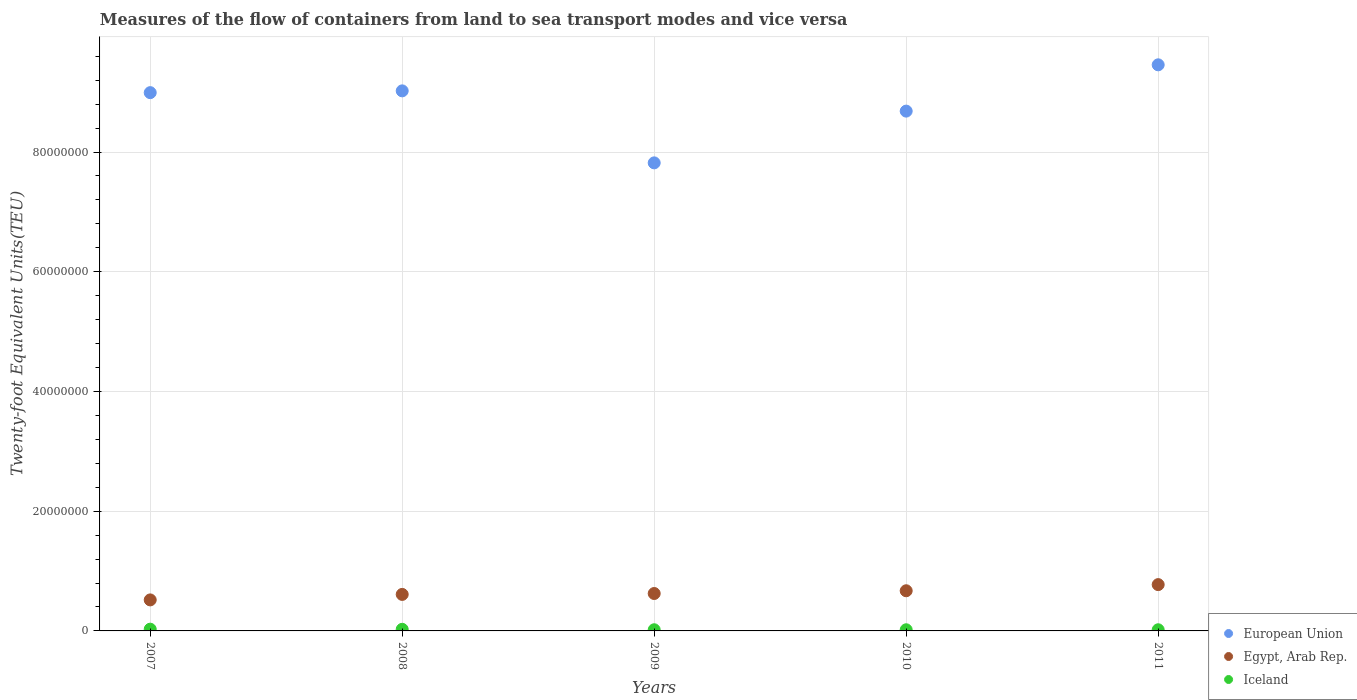What is the container port traffic in Iceland in 2011?
Ensure brevity in your answer.  1.94e+05. Across all years, what is the maximum container port traffic in European Union?
Your answer should be compact. 9.46e+07. Across all years, what is the minimum container port traffic in Iceland?
Make the answer very short. 1.93e+05. In which year was the container port traffic in European Union maximum?
Ensure brevity in your answer.  2011. In which year was the container port traffic in Egypt, Arab Rep. minimum?
Your answer should be compact. 2007. What is the total container port traffic in European Union in the graph?
Offer a very short reply. 4.40e+08. What is the difference between the container port traffic in European Union in 2008 and that in 2010?
Offer a terse response. 3.38e+06. What is the difference between the container port traffic in European Union in 2007 and the container port traffic in Iceland in 2010?
Make the answer very short. 8.97e+07. What is the average container port traffic in Iceland per year?
Give a very brief answer. 2.28e+05. In the year 2008, what is the difference between the container port traffic in Egypt, Arab Rep. and container port traffic in European Union?
Provide a succinct answer. -8.41e+07. In how many years, is the container port traffic in Iceland greater than 40000000 TEU?
Keep it short and to the point. 0. What is the ratio of the container port traffic in Egypt, Arab Rep. in 2008 to that in 2010?
Provide a short and direct response. 0.91. Is the container port traffic in European Union in 2007 less than that in 2010?
Keep it short and to the point. No. What is the difference between the highest and the second highest container port traffic in Iceland?
Provide a short and direct response. 2.46e+04. What is the difference between the highest and the lowest container port traffic in European Union?
Make the answer very short. 1.64e+07. In how many years, is the container port traffic in European Union greater than the average container port traffic in European Union taken over all years?
Keep it short and to the point. 3. Does the container port traffic in Iceland monotonically increase over the years?
Keep it short and to the point. No. Does the graph contain grids?
Make the answer very short. Yes. How many legend labels are there?
Offer a very short reply. 3. What is the title of the graph?
Ensure brevity in your answer.  Measures of the flow of containers from land to sea transport modes and vice versa. Does "Togo" appear as one of the legend labels in the graph?
Provide a short and direct response. No. What is the label or title of the X-axis?
Your response must be concise. Years. What is the label or title of the Y-axis?
Offer a very short reply. Twenty-foot Equivalent Units(TEU). What is the Twenty-foot Equivalent Units(TEU) in European Union in 2007?
Your answer should be very brief. 8.99e+07. What is the Twenty-foot Equivalent Units(TEU) of Egypt, Arab Rep. in 2007?
Give a very brief answer. 5.18e+06. What is the Twenty-foot Equivalent Units(TEU) in Iceland in 2007?
Ensure brevity in your answer.  2.92e+05. What is the Twenty-foot Equivalent Units(TEU) in European Union in 2008?
Keep it short and to the point. 9.02e+07. What is the Twenty-foot Equivalent Units(TEU) in Egypt, Arab Rep. in 2008?
Offer a very short reply. 6.10e+06. What is the Twenty-foot Equivalent Units(TEU) of Iceland in 2008?
Your answer should be very brief. 2.67e+05. What is the Twenty-foot Equivalent Units(TEU) in European Union in 2009?
Offer a very short reply. 7.82e+07. What is the Twenty-foot Equivalent Units(TEU) of Egypt, Arab Rep. in 2009?
Provide a short and direct response. 6.25e+06. What is the Twenty-foot Equivalent Units(TEU) in Iceland in 2009?
Give a very brief answer. 1.94e+05. What is the Twenty-foot Equivalent Units(TEU) of European Union in 2010?
Offer a very short reply. 8.68e+07. What is the Twenty-foot Equivalent Units(TEU) in Egypt, Arab Rep. in 2010?
Offer a very short reply. 6.71e+06. What is the Twenty-foot Equivalent Units(TEU) in Iceland in 2010?
Give a very brief answer. 1.93e+05. What is the Twenty-foot Equivalent Units(TEU) in European Union in 2011?
Your response must be concise. 9.46e+07. What is the Twenty-foot Equivalent Units(TEU) in Egypt, Arab Rep. in 2011?
Provide a succinct answer. 7.74e+06. What is the Twenty-foot Equivalent Units(TEU) of Iceland in 2011?
Ensure brevity in your answer.  1.94e+05. Across all years, what is the maximum Twenty-foot Equivalent Units(TEU) in European Union?
Keep it short and to the point. 9.46e+07. Across all years, what is the maximum Twenty-foot Equivalent Units(TEU) of Egypt, Arab Rep.?
Give a very brief answer. 7.74e+06. Across all years, what is the maximum Twenty-foot Equivalent Units(TEU) of Iceland?
Offer a very short reply. 2.92e+05. Across all years, what is the minimum Twenty-foot Equivalent Units(TEU) in European Union?
Your answer should be very brief. 7.82e+07. Across all years, what is the minimum Twenty-foot Equivalent Units(TEU) of Egypt, Arab Rep.?
Keep it short and to the point. 5.18e+06. Across all years, what is the minimum Twenty-foot Equivalent Units(TEU) of Iceland?
Keep it short and to the point. 1.93e+05. What is the total Twenty-foot Equivalent Units(TEU) in European Union in the graph?
Your response must be concise. 4.40e+08. What is the total Twenty-foot Equivalent Units(TEU) in Egypt, Arab Rep. in the graph?
Ensure brevity in your answer.  3.20e+07. What is the total Twenty-foot Equivalent Units(TEU) of Iceland in the graph?
Provide a short and direct response. 1.14e+06. What is the difference between the Twenty-foot Equivalent Units(TEU) in European Union in 2007 and that in 2008?
Offer a very short reply. -2.98e+05. What is the difference between the Twenty-foot Equivalent Units(TEU) in Egypt, Arab Rep. in 2007 and that in 2008?
Ensure brevity in your answer.  -9.18e+05. What is the difference between the Twenty-foot Equivalent Units(TEU) of Iceland in 2007 and that in 2008?
Make the answer very short. 2.46e+04. What is the difference between the Twenty-foot Equivalent Units(TEU) in European Union in 2007 and that in 2009?
Give a very brief answer. 1.17e+07. What is the difference between the Twenty-foot Equivalent Units(TEU) in Egypt, Arab Rep. in 2007 and that in 2009?
Provide a succinct answer. -1.07e+06. What is the difference between the Twenty-foot Equivalent Units(TEU) of Iceland in 2007 and that in 2009?
Keep it short and to the point. 9.79e+04. What is the difference between the Twenty-foot Equivalent Units(TEU) in European Union in 2007 and that in 2010?
Your response must be concise. 3.09e+06. What is the difference between the Twenty-foot Equivalent Units(TEU) of Egypt, Arab Rep. in 2007 and that in 2010?
Your response must be concise. -1.53e+06. What is the difference between the Twenty-foot Equivalent Units(TEU) in Iceland in 2007 and that in 2010?
Ensure brevity in your answer.  9.90e+04. What is the difference between the Twenty-foot Equivalent Units(TEU) of European Union in 2007 and that in 2011?
Provide a short and direct response. -4.65e+06. What is the difference between the Twenty-foot Equivalent Units(TEU) of Egypt, Arab Rep. in 2007 and that in 2011?
Your answer should be very brief. -2.56e+06. What is the difference between the Twenty-foot Equivalent Units(TEU) of Iceland in 2007 and that in 2011?
Your response must be concise. 9.82e+04. What is the difference between the Twenty-foot Equivalent Units(TEU) of European Union in 2008 and that in 2009?
Offer a very short reply. 1.20e+07. What is the difference between the Twenty-foot Equivalent Units(TEU) of Egypt, Arab Rep. in 2008 and that in 2009?
Offer a very short reply. -1.51e+05. What is the difference between the Twenty-foot Equivalent Units(TEU) in Iceland in 2008 and that in 2009?
Offer a very short reply. 7.33e+04. What is the difference between the Twenty-foot Equivalent Units(TEU) of European Union in 2008 and that in 2010?
Provide a short and direct response. 3.38e+06. What is the difference between the Twenty-foot Equivalent Units(TEU) in Egypt, Arab Rep. in 2008 and that in 2010?
Offer a very short reply. -6.10e+05. What is the difference between the Twenty-foot Equivalent Units(TEU) of Iceland in 2008 and that in 2010?
Your answer should be very brief. 7.44e+04. What is the difference between the Twenty-foot Equivalent Units(TEU) of European Union in 2008 and that in 2011?
Your answer should be very brief. -4.35e+06. What is the difference between the Twenty-foot Equivalent Units(TEU) of Egypt, Arab Rep. in 2008 and that in 2011?
Give a very brief answer. -1.64e+06. What is the difference between the Twenty-foot Equivalent Units(TEU) in Iceland in 2008 and that in 2011?
Your answer should be very brief. 7.37e+04. What is the difference between the Twenty-foot Equivalent Units(TEU) in European Union in 2009 and that in 2010?
Offer a very short reply. -8.65e+06. What is the difference between the Twenty-foot Equivalent Units(TEU) of Egypt, Arab Rep. in 2009 and that in 2010?
Offer a terse response. -4.59e+05. What is the difference between the Twenty-foot Equivalent Units(TEU) in Iceland in 2009 and that in 2010?
Provide a succinct answer. 1038. What is the difference between the Twenty-foot Equivalent Units(TEU) of European Union in 2009 and that in 2011?
Your answer should be very brief. -1.64e+07. What is the difference between the Twenty-foot Equivalent Units(TEU) of Egypt, Arab Rep. in 2009 and that in 2011?
Provide a succinct answer. -1.49e+06. What is the difference between the Twenty-foot Equivalent Units(TEU) of Iceland in 2009 and that in 2011?
Provide a short and direct response. 316. What is the difference between the Twenty-foot Equivalent Units(TEU) of European Union in 2010 and that in 2011?
Offer a terse response. -7.73e+06. What is the difference between the Twenty-foot Equivalent Units(TEU) in Egypt, Arab Rep. in 2010 and that in 2011?
Keep it short and to the point. -1.03e+06. What is the difference between the Twenty-foot Equivalent Units(TEU) of Iceland in 2010 and that in 2011?
Your answer should be very brief. -722. What is the difference between the Twenty-foot Equivalent Units(TEU) of European Union in 2007 and the Twenty-foot Equivalent Units(TEU) of Egypt, Arab Rep. in 2008?
Keep it short and to the point. 8.38e+07. What is the difference between the Twenty-foot Equivalent Units(TEU) in European Union in 2007 and the Twenty-foot Equivalent Units(TEU) in Iceland in 2008?
Ensure brevity in your answer.  8.97e+07. What is the difference between the Twenty-foot Equivalent Units(TEU) in Egypt, Arab Rep. in 2007 and the Twenty-foot Equivalent Units(TEU) in Iceland in 2008?
Keep it short and to the point. 4.91e+06. What is the difference between the Twenty-foot Equivalent Units(TEU) in European Union in 2007 and the Twenty-foot Equivalent Units(TEU) in Egypt, Arab Rep. in 2009?
Ensure brevity in your answer.  8.37e+07. What is the difference between the Twenty-foot Equivalent Units(TEU) in European Union in 2007 and the Twenty-foot Equivalent Units(TEU) in Iceland in 2009?
Provide a short and direct response. 8.97e+07. What is the difference between the Twenty-foot Equivalent Units(TEU) of Egypt, Arab Rep. in 2007 and the Twenty-foot Equivalent Units(TEU) of Iceland in 2009?
Provide a succinct answer. 4.99e+06. What is the difference between the Twenty-foot Equivalent Units(TEU) of European Union in 2007 and the Twenty-foot Equivalent Units(TEU) of Egypt, Arab Rep. in 2010?
Provide a succinct answer. 8.32e+07. What is the difference between the Twenty-foot Equivalent Units(TEU) of European Union in 2007 and the Twenty-foot Equivalent Units(TEU) of Iceland in 2010?
Offer a terse response. 8.97e+07. What is the difference between the Twenty-foot Equivalent Units(TEU) of Egypt, Arab Rep. in 2007 and the Twenty-foot Equivalent Units(TEU) of Iceland in 2010?
Give a very brief answer. 4.99e+06. What is the difference between the Twenty-foot Equivalent Units(TEU) in European Union in 2007 and the Twenty-foot Equivalent Units(TEU) in Egypt, Arab Rep. in 2011?
Give a very brief answer. 8.22e+07. What is the difference between the Twenty-foot Equivalent Units(TEU) of European Union in 2007 and the Twenty-foot Equivalent Units(TEU) of Iceland in 2011?
Ensure brevity in your answer.  8.97e+07. What is the difference between the Twenty-foot Equivalent Units(TEU) in Egypt, Arab Rep. in 2007 and the Twenty-foot Equivalent Units(TEU) in Iceland in 2011?
Provide a short and direct response. 4.99e+06. What is the difference between the Twenty-foot Equivalent Units(TEU) in European Union in 2008 and the Twenty-foot Equivalent Units(TEU) in Egypt, Arab Rep. in 2009?
Provide a short and direct response. 8.40e+07. What is the difference between the Twenty-foot Equivalent Units(TEU) in European Union in 2008 and the Twenty-foot Equivalent Units(TEU) in Iceland in 2009?
Offer a very short reply. 9.00e+07. What is the difference between the Twenty-foot Equivalent Units(TEU) of Egypt, Arab Rep. in 2008 and the Twenty-foot Equivalent Units(TEU) of Iceland in 2009?
Offer a terse response. 5.91e+06. What is the difference between the Twenty-foot Equivalent Units(TEU) of European Union in 2008 and the Twenty-foot Equivalent Units(TEU) of Egypt, Arab Rep. in 2010?
Offer a very short reply. 8.35e+07. What is the difference between the Twenty-foot Equivalent Units(TEU) in European Union in 2008 and the Twenty-foot Equivalent Units(TEU) in Iceland in 2010?
Offer a very short reply. 9.00e+07. What is the difference between the Twenty-foot Equivalent Units(TEU) in Egypt, Arab Rep. in 2008 and the Twenty-foot Equivalent Units(TEU) in Iceland in 2010?
Your response must be concise. 5.91e+06. What is the difference between the Twenty-foot Equivalent Units(TEU) in European Union in 2008 and the Twenty-foot Equivalent Units(TEU) in Egypt, Arab Rep. in 2011?
Your answer should be compact. 8.25e+07. What is the difference between the Twenty-foot Equivalent Units(TEU) of European Union in 2008 and the Twenty-foot Equivalent Units(TEU) of Iceland in 2011?
Give a very brief answer. 9.00e+07. What is the difference between the Twenty-foot Equivalent Units(TEU) in Egypt, Arab Rep. in 2008 and the Twenty-foot Equivalent Units(TEU) in Iceland in 2011?
Your answer should be very brief. 5.91e+06. What is the difference between the Twenty-foot Equivalent Units(TEU) in European Union in 2009 and the Twenty-foot Equivalent Units(TEU) in Egypt, Arab Rep. in 2010?
Ensure brevity in your answer.  7.15e+07. What is the difference between the Twenty-foot Equivalent Units(TEU) of European Union in 2009 and the Twenty-foot Equivalent Units(TEU) of Iceland in 2010?
Your response must be concise. 7.80e+07. What is the difference between the Twenty-foot Equivalent Units(TEU) of Egypt, Arab Rep. in 2009 and the Twenty-foot Equivalent Units(TEU) of Iceland in 2010?
Give a very brief answer. 6.06e+06. What is the difference between the Twenty-foot Equivalent Units(TEU) in European Union in 2009 and the Twenty-foot Equivalent Units(TEU) in Egypt, Arab Rep. in 2011?
Provide a succinct answer. 7.05e+07. What is the difference between the Twenty-foot Equivalent Units(TEU) of European Union in 2009 and the Twenty-foot Equivalent Units(TEU) of Iceland in 2011?
Make the answer very short. 7.80e+07. What is the difference between the Twenty-foot Equivalent Units(TEU) in Egypt, Arab Rep. in 2009 and the Twenty-foot Equivalent Units(TEU) in Iceland in 2011?
Your answer should be compact. 6.06e+06. What is the difference between the Twenty-foot Equivalent Units(TEU) of European Union in 2010 and the Twenty-foot Equivalent Units(TEU) of Egypt, Arab Rep. in 2011?
Your answer should be very brief. 7.91e+07. What is the difference between the Twenty-foot Equivalent Units(TEU) in European Union in 2010 and the Twenty-foot Equivalent Units(TEU) in Iceland in 2011?
Offer a terse response. 8.66e+07. What is the difference between the Twenty-foot Equivalent Units(TEU) of Egypt, Arab Rep. in 2010 and the Twenty-foot Equivalent Units(TEU) of Iceland in 2011?
Your answer should be very brief. 6.52e+06. What is the average Twenty-foot Equivalent Units(TEU) of European Union per year?
Ensure brevity in your answer.  8.80e+07. What is the average Twenty-foot Equivalent Units(TEU) of Egypt, Arab Rep. per year?
Your response must be concise. 6.40e+06. What is the average Twenty-foot Equivalent Units(TEU) of Iceland per year?
Your answer should be compact. 2.28e+05. In the year 2007, what is the difference between the Twenty-foot Equivalent Units(TEU) in European Union and Twenty-foot Equivalent Units(TEU) in Egypt, Arab Rep.?
Your response must be concise. 8.47e+07. In the year 2007, what is the difference between the Twenty-foot Equivalent Units(TEU) of European Union and Twenty-foot Equivalent Units(TEU) of Iceland?
Your answer should be compact. 8.96e+07. In the year 2007, what is the difference between the Twenty-foot Equivalent Units(TEU) of Egypt, Arab Rep. and Twenty-foot Equivalent Units(TEU) of Iceland?
Offer a terse response. 4.89e+06. In the year 2008, what is the difference between the Twenty-foot Equivalent Units(TEU) in European Union and Twenty-foot Equivalent Units(TEU) in Egypt, Arab Rep.?
Keep it short and to the point. 8.41e+07. In the year 2008, what is the difference between the Twenty-foot Equivalent Units(TEU) of European Union and Twenty-foot Equivalent Units(TEU) of Iceland?
Keep it short and to the point. 9.00e+07. In the year 2008, what is the difference between the Twenty-foot Equivalent Units(TEU) in Egypt, Arab Rep. and Twenty-foot Equivalent Units(TEU) in Iceland?
Offer a terse response. 5.83e+06. In the year 2009, what is the difference between the Twenty-foot Equivalent Units(TEU) of European Union and Twenty-foot Equivalent Units(TEU) of Egypt, Arab Rep.?
Offer a very short reply. 7.19e+07. In the year 2009, what is the difference between the Twenty-foot Equivalent Units(TEU) in European Union and Twenty-foot Equivalent Units(TEU) in Iceland?
Make the answer very short. 7.80e+07. In the year 2009, what is the difference between the Twenty-foot Equivalent Units(TEU) of Egypt, Arab Rep. and Twenty-foot Equivalent Units(TEU) of Iceland?
Provide a succinct answer. 6.06e+06. In the year 2010, what is the difference between the Twenty-foot Equivalent Units(TEU) of European Union and Twenty-foot Equivalent Units(TEU) of Egypt, Arab Rep.?
Ensure brevity in your answer.  8.01e+07. In the year 2010, what is the difference between the Twenty-foot Equivalent Units(TEU) of European Union and Twenty-foot Equivalent Units(TEU) of Iceland?
Make the answer very short. 8.66e+07. In the year 2010, what is the difference between the Twenty-foot Equivalent Units(TEU) in Egypt, Arab Rep. and Twenty-foot Equivalent Units(TEU) in Iceland?
Your answer should be very brief. 6.52e+06. In the year 2011, what is the difference between the Twenty-foot Equivalent Units(TEU) of European Union and Twenty-foot Equivalent Units(TEU) of Egypt, Arab Rep.?
Keep it short and to the point. 8.68e+07. In the year 2011, what is the difference between the Twenty-foot Equivalent Units(TEU) in European Union and Twenty-foot Equivalent Units(TEU) in Iceland?
Make the answer very short. 9.44e+07. In the year 2011, what is the difference between the Twenty-foot Equivalent Units(TEU) of Egypt, Arab Rep. and Twenty-foot Equivalent Units(TEU) of Iceland?
Offer a terse response. 7.54e+06. What is the ratio of the Twenty-foot Equivalent Units(TEU) of Egypt, Arab Rep. in 2007 to that in 2008?
Make the answer very short. 0.85. What is the ratio of the Twenty-foot Equivalent Units(TEU) of Iceland in 2007 to that in 2008?
Ensure brevity in your answer.  1.09. What is the ratio of the Twenty-foot Equivalent Units(TEU) of European Union in 2007 to that in 2009?
Provide a short and direct response. 1.15. What is the ratio of the Twenty-foot Equivalent Units(TEU) in Egypt, Arab Rep. in 2007 to that in 2009?
Your response must be concise. 0.83. What is the ratio of the Twenty-foot Equivalent Units(TEU) in Iceland in 2007 to that in 2009?
Provide a succinct answer. 1.51. What is the ratio of the Twenty-foot Equivalent Units(TEU) in European Union in 2007 to that in 2010?
Ensure brevity in your answer.  1.04. What is the ratio of the Twenty-foot Equivalent Units(TEU) in Egypt, Arab Rep. in 2007 to that in 2010?
Give a very brief answer. 0.77. What is the ratio of the Twenty-foot Equivalent Units(TEU) in Iceland in 2007 to that in 2010?
Your answer should be compact. 1.51. What is the ratio of the Twenty-foot Equivalent Units(TEU) of European Union in 2007 to that in 2011?
Your answer should be very brief. 0.95. What is the ratio of the Twenty-foot Equivalent Units(TEU) of Egypt, Arab Rep. in 2007 to that in 2011?
Keep it short and to the point. 0.67. What is the ratio of the Twenty-foot Equivalent Units(TEU) in Iceland in 2007 to that in 2011?
Make the answer very short. 1.51. What is the ratio of the Twenty-foot Equivalent Units(TEU) of European Union in 2008 to that in 2009?
Ensure brevity in your answer.  1.15. What is the ratio of the Twenty-foot Equivalent Units(TEU) of Egypt, Arab Rep. in 2008 to that in 2009?
Ensure brevity in your answer.  0.98. What is the ratio of the Twenty-foot Equivalent Units(TEU) of Iceland in 2008 to that in 2009?
Offer a terse response. 1.38. What is the ratio of the Twenty-foot Equivalent Units(TEU) of European Union in 2008 to that in 2010?
Offer a very short reply. 1.04. What is the ratio of the Twenty-foot Equivalent Units(TEU) in Egypt, Arab Rep. in 2008 to that in 2010?
Your answer should be compact. 0.91. What is the ratio of the Twenty-foot Equivalent Units(TEU) in Iceland in 2008 to that in 2010?
Give a very brief answer. 1.39. What is the ratio of the Twenty-foot Equivalent Units(TEU) in European Union in 2008 to that in 2011?
Make the answer very short. 0.95. What is the ratio of the Twenty-foot Equivalent Units(TEU) of Egypt, Arab Rep. in 2008 to that in 2011?
Offer a terse response. 0.79. What is the ratio of the Twenty-foot Equivalent Units(TEU) of Iceland in 2008 to that in 2011?
Make the answer very short. 1.38. What is the ratio of the Twenty-foot Equivalent Units(TEU) in European Union in 2009 to that in 2010?
Make the answer very short. 0.9. What is the ratio of the Twenty-foot Equivalent Units(TEU) of Egypt, Arab Rep. in 2009 to that in 2010?
Ensure brevity in your answer.  0.93. What is the ratio of the Twenty-foot Equivalent Units(TEU) in Iceland in 2009 to that in 2010?
Keep it short and to the point. 1.01. What is the ratio of the Twenty-foot Equivalent Units(TEU) in European Union in 2009 to that in 2011?
Your response must be concise. 0.83. What is the ratio of the Twenty-foot Equivalent Units(TEU) of Egypt, Arab Rep. in 2009 to that in 2011?
Offer a very short reply. 0.81. What is the ratio of the Twenty-foot Equivalent Units(TEU) in European Union in 2010 to that in 2011?
Your answer should be compact. 0.92. What is the ratio of the Twenty-foot Equivalent Units(TEU) in Egypt, Arab Rep. in 2010 to that in 2011?
Provide a short and direct response. 0.87. What is the difference between the highest and the second highest Twenty-foot Equivalent Units(TEU) of European Union?
Provide a succinct answer. 4.35e+06. What is the difference between the highest and the second highest Twenty-foot Equivalent Units(TEU) in Egypt, Arab Rep.?
Provide a short and direct response. 1.03e+06. What is the difference between the highest and the second highest Twenty-foot Equivalent Units(TEU) in Iceland?
Offer a very short reply. 2.46e+04. What is the difference between the highest and the lowest Twenty-foot Equivalent Units(TEU) of European Union?
Your answer should be compact. 1.64e+07. What is the difference between the highest and the lowest Twenty-foot Equivalent Units(TEU) of Egypt, Arab Rep.?
Your answer should be very brief. 2.56e+06. What is the difference between the highest and the lowest Twenty-foot Equivalent Units(TEU) in Iceland?
Provide a succinct answer. 9.90e+04. 